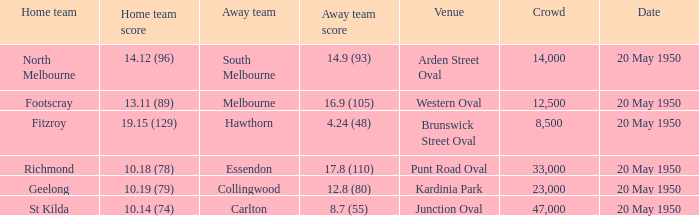Which team was the away team when the game was at punt road oval? Essendon. 